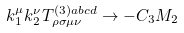Convert formula to latex. <formula><loc_0><loc_0><loc_500><loc_500>k _ { 1 } ^ { \mu } k _ { 2 } ^ { \nu } T _ { \rho \sigma \mu \nu } ^ { ( 3 ) a b c d } \rightarrow - C _ { 3 } M _ { 2 }</formula> 